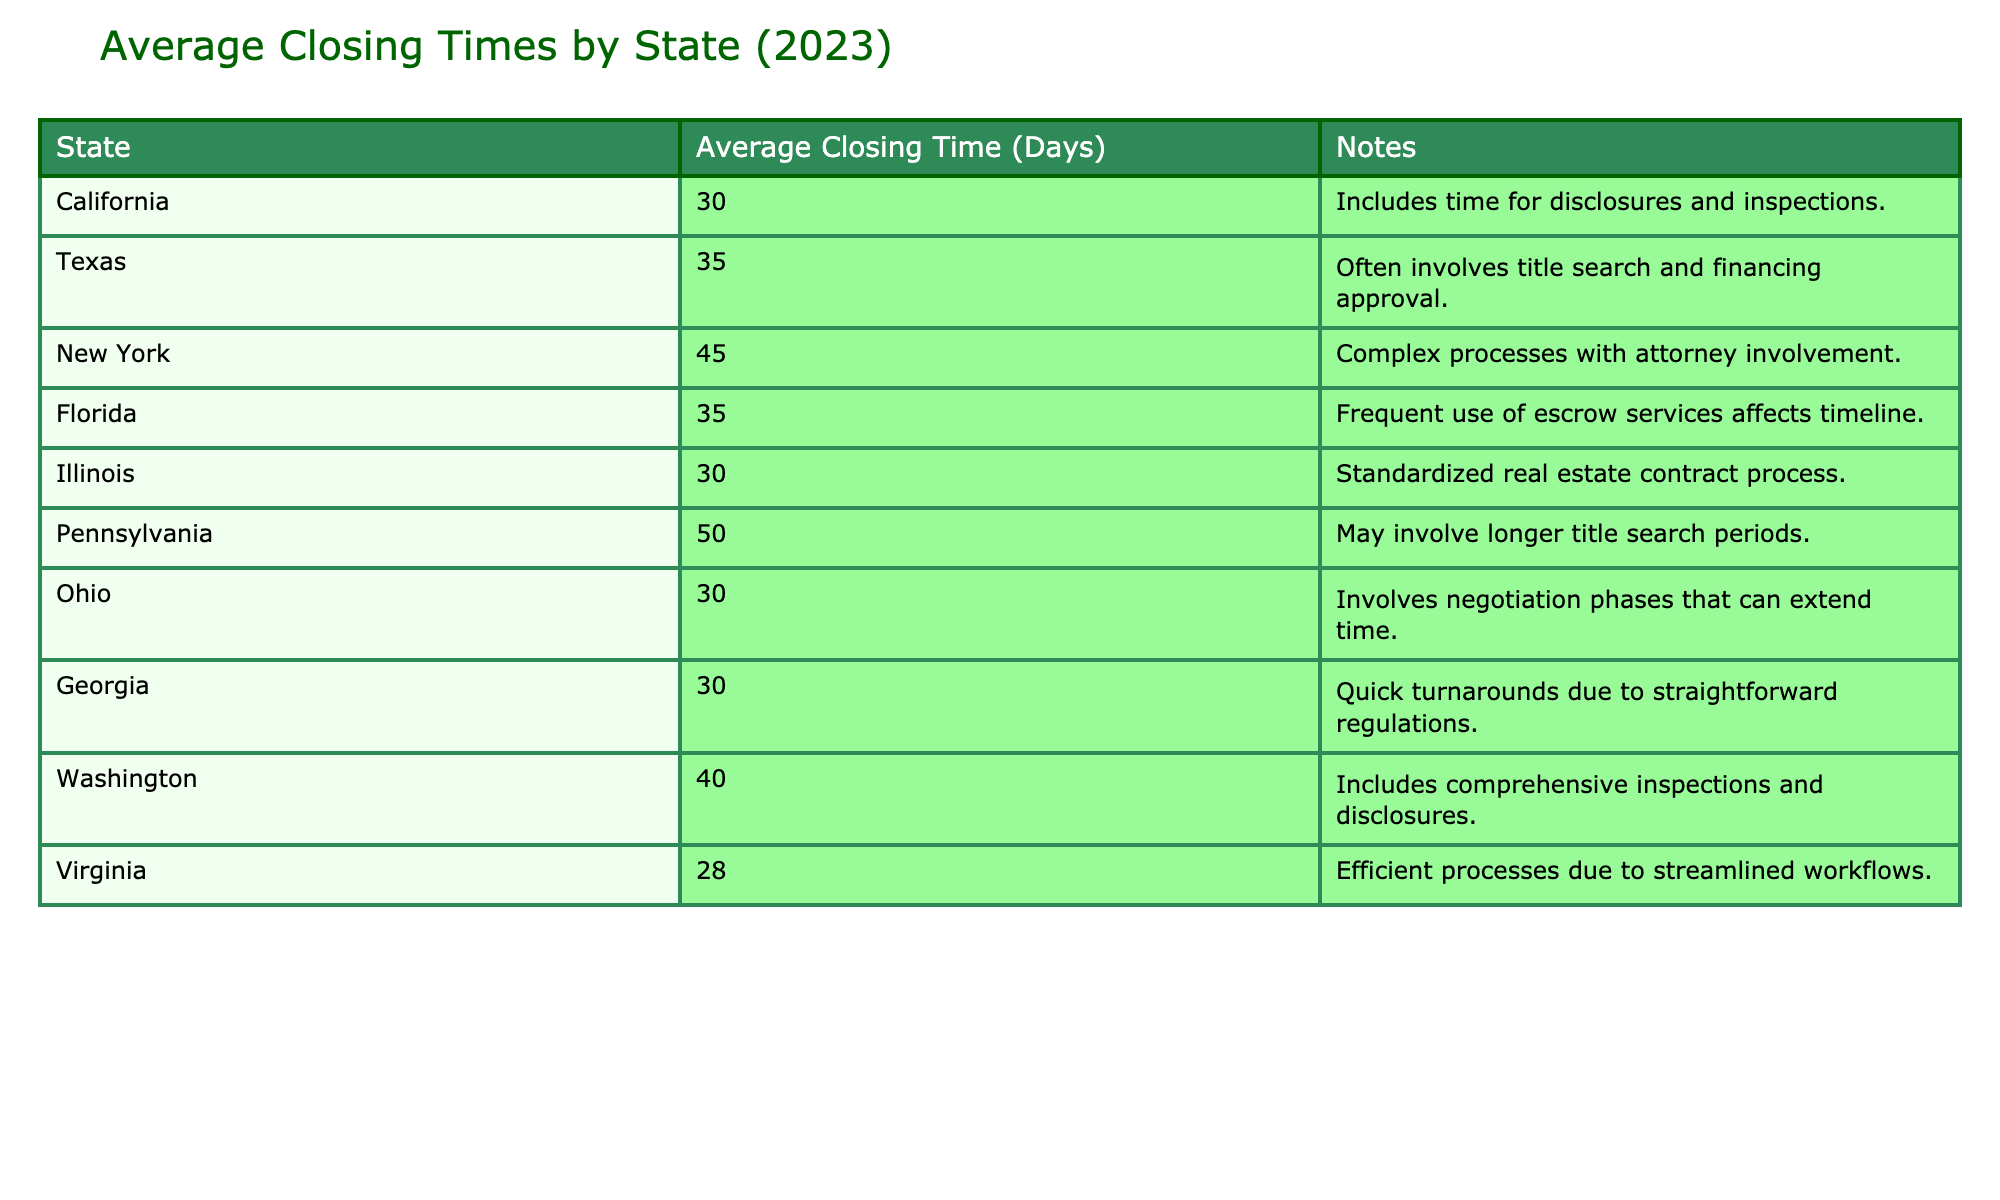What is the average closing time in Virginia? The table shows that the average closing time for Virginia is 28 days. This value can be found directly in the relevant row under the "Average Closing Time (Days)" column.
Answer: 28 Which state has the longest average closing time? By comparing the values in the "Average Closing Time (Days)" column, Pennsylvania has the longest average closing time at 50 days. This is the highest value among all listed states.
Answer: Pennsylvania Is it true that California has a shorter average closing time than Texas? From the table, California has an average closing time of 30 days and Texas has 35 days. Since 30 is less than 35, it is true that California has a shorter average closing time.
Answer: Yes What is the difference in average closing times between Florida and New York? Florida's average closing time is 35 days and New York's is 45 days. To find the difference, we subtract Florida's average from New York's: 45 - 35 = 10 days.
Answer: 10 days What is the average closing time of states that are known for quick turnarounds, such as Georgia and Virginia? Georgia has an average closing time of 30 days and Virginia has 28 days. To find the average, we sum these values (30 + 28) and divide by 2: (58 / 2) = 29 days.
Answer: 29 days Which two states have the same average closing time and what is it? The table shows that California, Illinois, and Ohio each have an average closing time of 30 days. So, the states that have the same closing time are California, Illinois, and Ohio, all at 30 days.
Answer: California, Illinois, Ohio - 30 days How does the average closing time in New York compare with the average closing time in Virginia? The average closing time in New York is 45 days while in Virginia it is 28 days. To compare, we see that New York's average is higher than Virginia's by 17 days: 45 - 28 = 17 days.
Answer: New York is 17 days longer Which states have closing times that are less than or equal to 30 days? Looking at the table, the states with closing times of 30 days or less are Virginia (28 days), California (30 days), Illinois (30 days), Ohio (30 days), and Georgia (30 days).
Answer: Virginia, California, Illinois, Ohio, Georgia What is the maximum and minimum closing time from the states listed? From the table, the minimum closing time is 28 days (Virginia) and the maximum is 50 days (Pennsylvania). Therefore, the range represents the shortest and longest averages.
Answer: Min: 28 days, Max: 50 days 